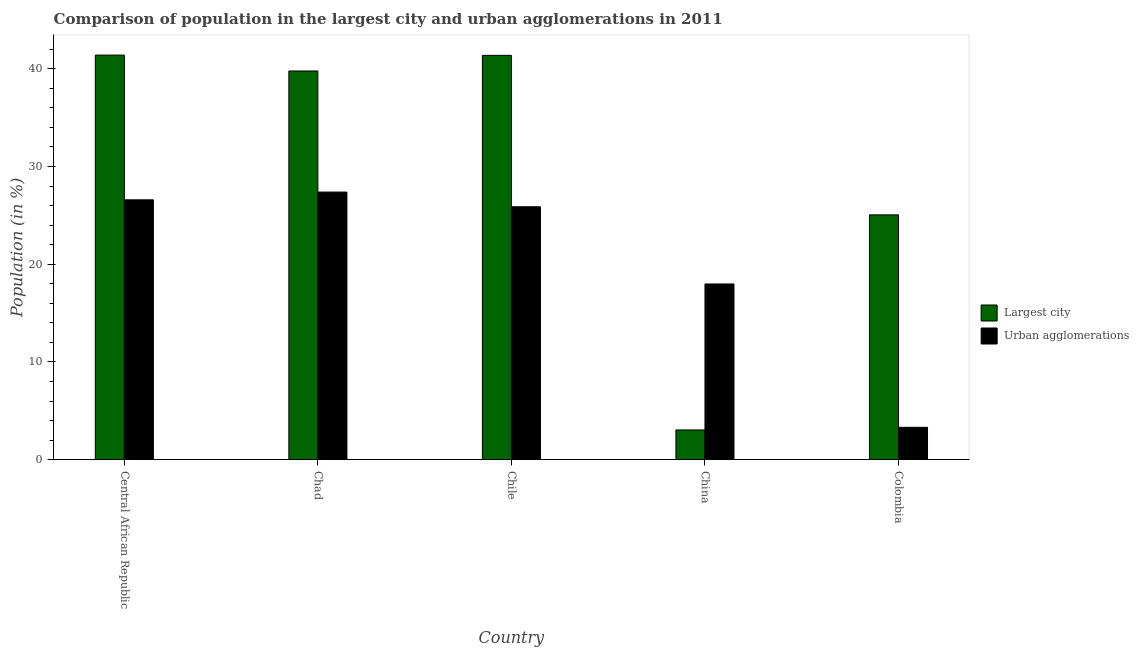How many groups of bars are there?
Provide a short and direct response. 5. How many bars are there on the 1st tick from the left?
Your answer should be very brief. 2. What is the label of the 4th group of bars from the left?
Keep it short and to the point. China. What is the population in urban agglomerations in Colombia?
Ensure brevity in your answer.  3.32. Across all countries, what is the maximum population in the largest city?
Your response must be concise. 41.4. Across all countries, what is the minimum population in urban agglomerations?
Your response must be concise. 3.32. In which country was the population in the largest city maximum?
Give a very brief answer. Central African Republic. In which country was the population in the largest city minimum?
Make the answer very short. China. What is the total population in the largest city in the graph?
Provide a short and direct response. 150.66. What is the difference between the population in urban agglomerations in Chad and that in Chile?
Provide a succinct answer. 1.5. What is the difference between the population in urban agglomerations in China and the population in the largest city in Chile?
Your response must be concise. -23.39. What is the average population in urban agglomerations per country?
Your answer should be very brief. 20.23. What is the difference between the population in the largest city and population in urban agglomerations in Chad?
Give a very brief answer. 12.39. What is the ratio of the population in the largest city in Chile to that in Colombia?
Your answer should be compact. 1.65. Is the population in urban agglomerations in Chile less than that in Colombia?
Provide a short and direct response. No. Is the difference between the population in urban agglomerations in Central African Republic and Chad greater than the difference between the population in the largest city in Central African Republic and Chad?
Make the answer very short. No. What is the difference between the highest and the second highest population in urban agglomerations?
Your answer should be very brief. 0.79. What is the difference between the highest and the lowest population in the largest city?
Provide a succinct answer. 38.36. Is the sum of the population in the largest city in Chile and Colombia greater than the maximum population in urban agglomerations across all countries?
Your response must be concise. Yes. What does the 1st bar from the left in Colombia represents?
Your response must be concise. Largest city. What does the 1st bar from the right in Chad represents?
Offer a terse response. Urban agglomerations. How many bars are there?
Make the answer very short. 10. Are all the bars in the graph horizontal?
Your response must be concise. No. How many countries are there in the graph?
Provide a succinct answer. 5. Does the graph contain any zero values?
Offer a terse response. No. Does the graph contain grids?
Offer a very short reply. No. How many legend labels are there?
Provide a short and direct response. 2. How are the legend labels stacked?
Your response must be concise. Vertical. What is the title of the graph?
Ensure brevity in your answer.  Comparison of population in the largest city and urban agglomerations in 2011. Does "Exports" appear as one of the legend labels in the graph?
Your answer should be compact. No. What is the label or title of the Y-axis?
Offer a terse response. Population (in %). What is the Population (in %) of Largest city in Central African Republic?
Make the answer very short. 41.4. What is the Population (in %) in Urban agglomerations in Central African Republic?
Your response must be concise. 26.59. What is the Population (in %) in Largest city in Chad?
Provide a short and direct response. 39.78. What is the Population (in %) of Urban agglomerations in Chad?
Make the answer very short. 27.39. What is the Population (in %) in Largest city in Chile?
Offer a terse response. 41.38. What is the Population (in %) of Urban agglomerations in Chile?
Make the answer very short. 25.88. What is the Population (in %) of Largest city in China?
Ensure brevity in your answer.  3.04. What is the Population (in %) of Urban agglomerations in China?
Provide a succinct answer. 17.98. What is the Population (in %) of Largest city in Colombia?
Make the answer very short. 25.05. What is the Population (in %) in Urban agglomerations in Colombia?
Offer a very short reply. 3.32. Across all countries, what is the maximum Population (in %) in Largest city?
Provide a short and direct response. 41.4. Across all countries, what is the maximum Population (in %) in Urban agglomerations?
Give a very brief answer. 27.39. Across all countries, what is the minimum Population (in %) of Largest city?
Ensure brevity in your answer.  3.04. Across all countries, what is the minimum Population (in %) in Urban agglomerations?
Keep it short and to the point. 3.32. What is the total Population (in %) in Largest city in the graph?
Offer a very short reply. 150.66. What is the total Population (in %) of Urban agglomerations in the graph?
Provide a succinct answer. 101.16. What is the difference between the Population (in %) of Largest city in Central African Republic and that in Chad?
Your answer should be compact. 1.62. What is the difference between the Population (in %) of Urban agglomerations in Central African Republic and that in Chad?
Give a very brief answer. -0.79. What is the difference between the Population (in %) in Largest city in Central African Republic and that in Chile?
Make the answer very short. 0.03. What is the difference between the Population (in %) in Urban agglomerations in Central African Republic and that in Chile?
Ensure brevity in your answer.  0.71. What is the difference between the Population (in %) of Largest city in Central African Republic and that in China?
Your answer should be very brief. 38.36. What is the difference between the Population (in %) in Urban agglomerations in Central African Republic and that in China?
Offer a very short reply. 8.61. What is the difference between the Population (in %) of Largest city in Central African Republic and that in Colombia?
Your answer should be very brief. 16.35. What is the difference between the Population (in %) of Urban agglomerations in Central African Republic and that in Colombia?
Your answer should be very brief. 23.28. What is the difference between the Population (in %) in Largest city in Chad and that in Chile?
Make the answer very short. -1.6. What is the difference between the Population (in %) of Urban agglomerations in Chad and that in Chile?
Ensure brevity in your answer.  1.5. What is the difference between the Population (in %) of Largest city in Chad and that in China?
Your response must be concise. 36.73. What is the difference between the Population (in %) of Urban agglomerations in Chad and that in China?
Offer a very short reply. 9.4. What is the difference between the Population (in %) in Largest city in Chad and that in Colombia?
Make the answer very short. 14.72. What is the difference between the Population (in %) in Urban agglomerations in Chad and that in Colombia?
Give a very brief answer. 24.07. What is the difference between the Population (in %) of Largest city in Chile and that in China?
Keep it short and to the point. 38.33. What is the difference between the Population (in %) of Urban agglomerations in Chile and that in China?
Your answer should be very brief. 7.9. What is the difference between the Population (in %) in Largest city in Chile and that in Colombia?
Your answer should be very brief. 16.32. What is the difference between the Population (in %) in Urban agglomerations in Chile and that in Colombia?
Offer a terse response. 22.57. What is the difference between the Population (in %) in Largest city in China and that in Colombia?
Give a very brief answer. -22.01. What is the difference between the Population (in %) in Urban agglomerations in China and that in Colombia?
Your answer should be very brief. 14.67. What is the difference between the Population (in %) in Largest city in Central African Republic and the Population (in %) in Urban agglomerations in Chad?
Give a very brief answer. 14.02. What is the difference between the Population (in %) in Largest city in Central African Republic and the Population (in %) in Urban agglomerations in Chile?
Your response must be concise. 15.52. What is the difference between the Population (in %) in Largest city in Central African Republic and the Population (in %) in Urban agglomerations in China?
Your response must be concise. 23.42. What is the difference between the Population (in %) in Largest city in Central African Republic and the Population (in %) in Urban agglomerations in Colombia?
Provide a succinct answer. 38.09. What is the difference between the Population (in %) in Largest city in Chad and the Population (in %) in Urban agglomerations in Chile?
Offer a terse response. 13.9. What is the difference between the Population (in %) in Largest city in Chad and the Population (in %) in Urban agglomerations in China?
Keep it short and to the point. 21.8. What is the difference between the Population (in %) of Largest city in Chad and the Population (in %) of Urban agglomerations in Colombia?
Ensure brevity in your answer.  36.46. What is the difference between the Population (in %) in Largest city in Chile and the Population (in %) in Urban agglomerations in China?
Offer a very short reply. 23.39. What is the difference between the Population (in %) in Largest city in Chile and the Population (in %) in Urban agglomerations in Colombia?
Keep it short and to the point. 38.06. What is the difference between the Population (in %) of Largest city in China and the Population (in %) of Urban agglomerations in Colombia?
Your answer should be very brief. -0.27. What is the average Population (in %) of Largest city per country?
Your answer should be compact. 30.13. What is the average Population (in %) of Urban agglomerations per country?
Give a very brief answer. 20.23. What is the difference between the Population (in %) of Largest city and Population (in %) of Urban agglomerations in Central African Republic?
Your answer should be very brief. 14.81. What is the difference between the Population (in %) of Largest city and Population (in %) of Urban agglomerations in Chad?
Your answer should be compact. 12.39. What is the difference between the Population (in %) in Largest city and Population (in %) in Urban agglomerations in Chile?
Make the answer very short. 15.49. What is the difference between the Population (in %) in Largest city and Population (in %) in Urban agglomerations in China?
Provide a short and direct response. -14.94. What is the difference between the Population (in %) of Largest city and Population (in %) of Urban agglomerations in Colombia?
Give a very brief answer. 21.74. What is the ratio of the Population (in %) in Largest city in Central African Republic to that in Chad?
Give a very brief answer. 1.04. What is the ratio of the Population (in %) of Urban agglomerations in Central African Republic to that in Chile?
Offer a terse response. 1.03. What is the ratio of the Population (in %) in Largest city in Central African Republic to that in China?
Ensure brevity in your answer.  13.6. What is the ratio of the Population (in %) of Urban agglomerations in Central African Republic to that in China?
Make the answer very short. 1.48. What is the ratio of the Population (in %) of Largest city in Central African Republic to that in Colombia?
Give a very brief answer. 1.65. What is the ratio of the Population (in %) of Urban agglomerations in Central African Republic to that in Colombia?
Provide a short and direct response. 8.02. What is the ratio of the Population (in %) in Largest city in Chad to that in Chile?
Provide a succinct answer. 0.96. What is the ratio of the Population (in %) of Urban agglomerations in Chad to that in Chile?
Keep it short and to the point. 1.06. What is the ratio of the Population (in %) of Largest city in Chad to that in China?
Offer a terse response. 13.07. What is the ratio of the Population (in %) in Urban agglomerations in Chad to that in China?
Ensure brevity in your answer.  1.52. What is the ratio of the Population (in %) in Largest city in Chad to that in Colombia?
Offer a very short reply. 1.59. What is the ratio of the Population (in %) of Urban agglomerations in Chad to that in Colombia?
Provide a succinct answer. 8.26. What is the ratio of the Population (in %) in Largest city in Chile to that in China?
Your answer should be compact. 13.59. What is the ratio of the Population (in %) in Urban agglomerations in Chile to that in China?
Your response must be concise. 1.44. What is the ratio of the Population (in %) of Largest city in Chile to that in Colombia?
Keep it short and to the point. 1.65. What is the ratio of the Population (in %) of Urban agglomerations in Chile to that in Colombia?
Your answer should be compact. 7.81. What is the ratio of the Population (in %) of Largest city in China to that in Colombia?
Keep it short and to the point. 0.12. What is the ratio of the Population (in %) in Urban agglomerations in China to that in Colombia?
Your answer should be very brief. 5.42. What is the difference between the highest and the second highest Population (in %) of Largest city?
Your response must be concise. 0.03. What is the difference between the highest and the second highest Population (in %) in Urban agglomerations?
Offer a terse response. 0.79. What is the difference between the highest and the lowest Population (in %) in Largest city?
Provide a succinct answer. 38.36. What is the difference between the highest and the lowest Population (in %) in Urban agglomerations?
Your answer should be compact. 24.07. 